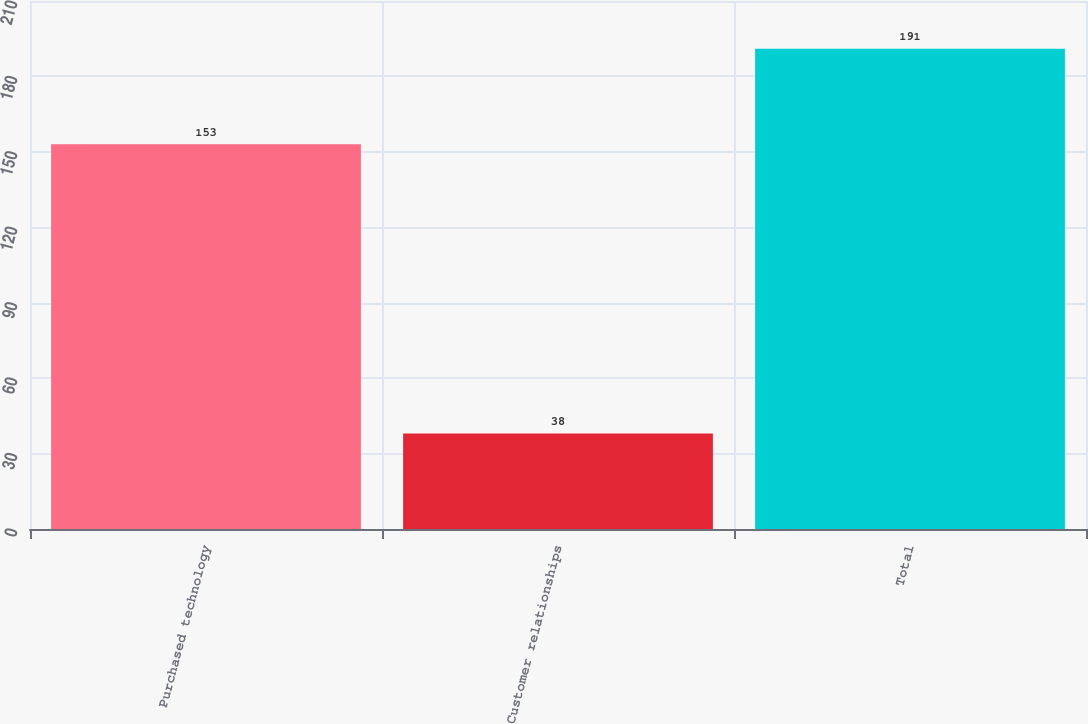Convert chart. <chart><loc_0><loc_0><loc_500><loc_500><bar_chart><fcel>Purchased technology<fcel>Customer relationships<fcel>Total<nl><fcel>153<fcel>38<fcel>191<nl></chart> 